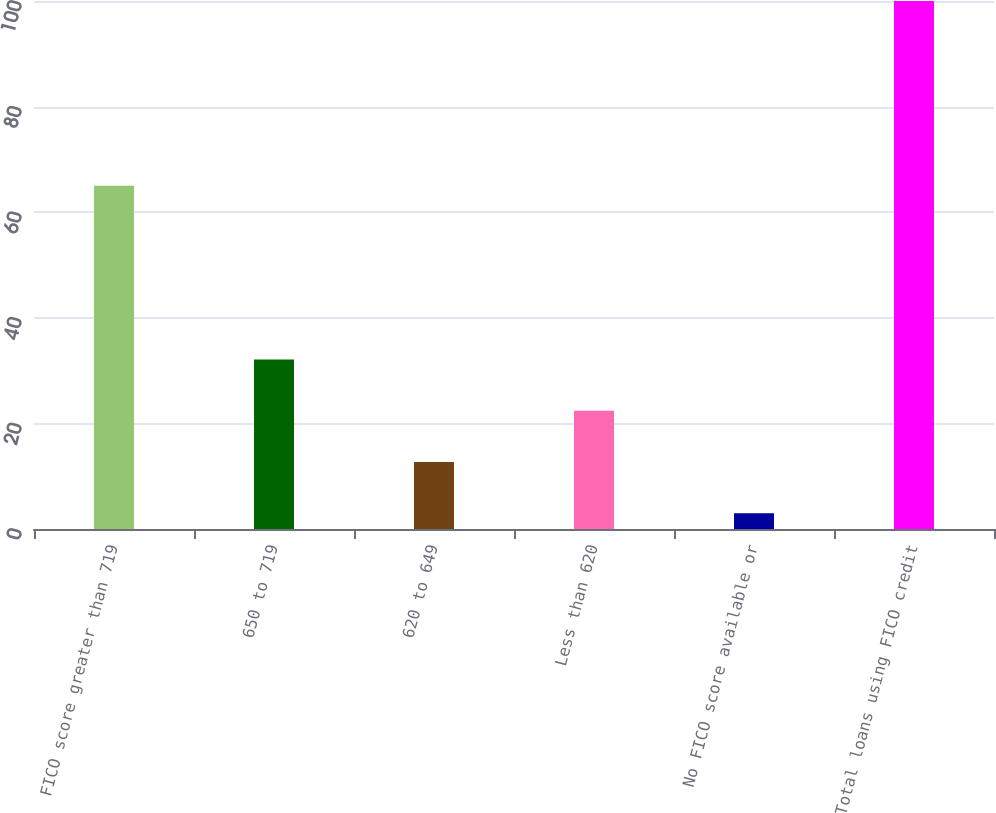Convert chart. <chart><loc_0><loc_0><loc_500><loc_500><bar_chart><fcel>FICO score greater than 719<fcel>650 to 719<fcel>620 to 649<fcel>Less than 620<fcel>No FICO score available or<fcel>Total loans using FICO credit<nl><fcel>65<fcel>32.1<fcel>12.7<fcel>22.4<fcel>3<fcel>100<nl></chart> 